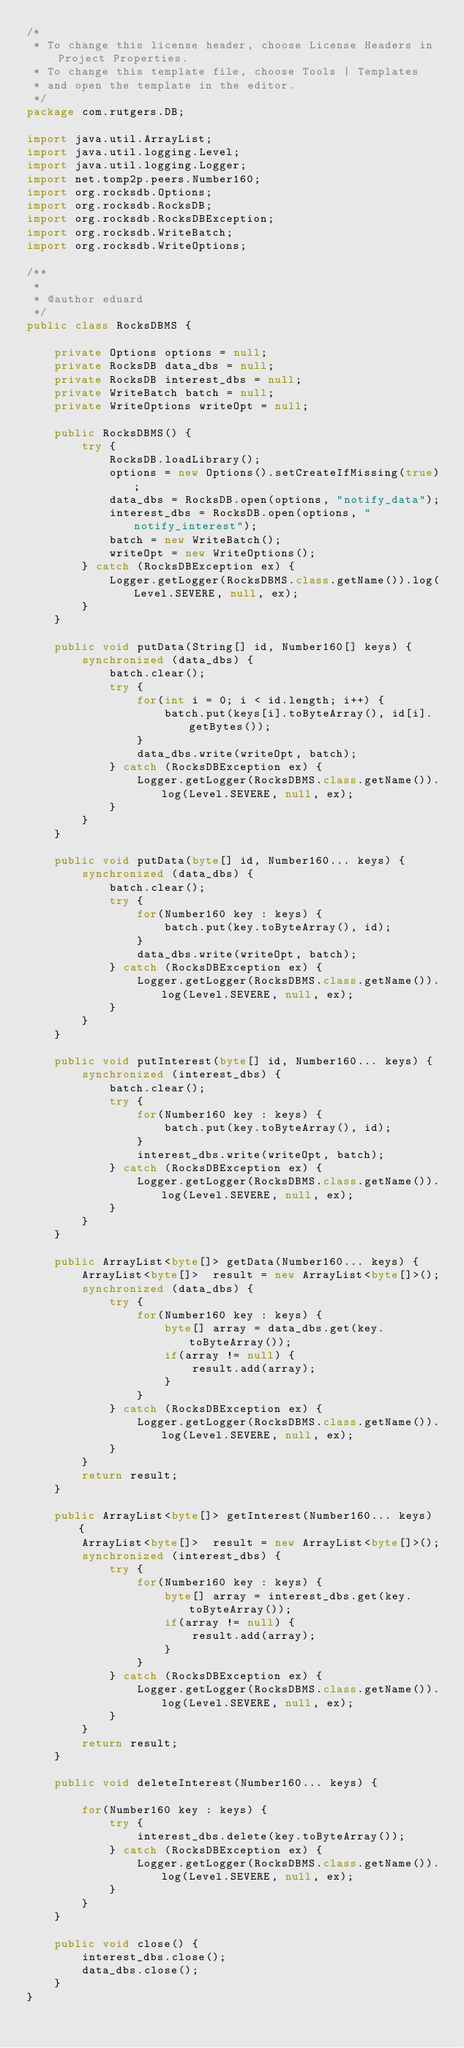<code> <loc_0><loc_0><loc_500><loc_500><_Java_>/*
 * To change this license header, choose License Headers in Project Properties.
 * To change this template file, choose Tools | Templates
 * and open the template in the editor.
 */
package com.rutgers.DB;

import java.util.ArrayList;
import java.util.logging.Level;
import java.util.logging.Logger;
import net.tomp2p.peers.Number160;
import org.rocksdb.Options;
import org.rocksdb.RocksDB;
import org.rocksdb.RocksDBException;
import org.rocksdb.WriteBatch;
import org.rocksdb.WriteOptions;

/**
 *
 * @author eduard
 */
public class RocksDBMS {
    
    private Options options = null;
    private RocksDB data_dbs = null;
    private RocksDB interest_dbs = null;
    private WriteBatch batch = null;
    private WriteOptions writeOpt = null;
    
    public RocksDBMS() {
        try {
            RocksDB.loadLibrary();            
            options = new Options().setCreateIfMissing(true);
            data_dbs = RocksDB.open(options, "notify_data");
            interest_dbs = RocksDB.open(options, "notify_interest");
            batch = new WriteBatch();
            writeOpt = new WriteOptions();
        } catch (RocksDBException ex) {
            Logger.getLogger(RocksDBMS.class.getName()).log(Level.SEVERE, null, ex);
        }
    }
    
    public void putData(String[] id, Number160[] keys) {
        synchronized (data_dbs) {
            batch.clear();
            try {
                for(int i = 0; i < id.length; i++) {
                    batch.put(keys[i].toByteArray(), id[i].getBytes());
                }
                data_dbs.write(writeOpt, batch);
            } catch (RocksDBException ex) {
                Logger.getLogger(RocksDBMS.class.getName()).log(Level.SEVERE, null, ex);
            }
        }
    }
    
    public void putData(byte[] id, Number160... keys) {
        synchronized (data_dbs) {
            batch.clear();
            try {
                for(Number160 key : keys) {
                    batch.put(key.toByteArray(), id);
                }
                data_dbs.write(writeOpt, batch);
            } catch (RocksDBException ex) {
                Logger.getLogger(RocksDBMS.class.getName()).log(Level.SEVERE, null, ex);
            }
        }
    }
    
    public void putInterest(byte[] id, Number160... keys) {
        synchronized (interest_dbs) {
            batch.clear();
            try {
                for(Number160 key : keys) {
                    batch.put(key.toByteArray(), id);
                }
                interest_dbs.write(writeOpt, batch);
            } catch (RocksDBException ex) {
                Logger.getLogger(RocksDBMS.class.getName()).log(Level.SEVERE, null, ex);
            }
        }
    }
    
    public ArrayList<byte[]> getData(Number160... keys) {
        ArrayList<byte[]>  result = new ArrayList<byte[]>();
        synchronized (data_dbs) {
            try {
                for(Number160 key : keys) {                    
                    byte[] array = data_dbs.get(key.toByteArray());
                    if(array != null) {
                        result.add(array);
                    }
                }
            } catch (RocksDBException ex) {
                Logger.getLogger(RocksDBMS.class.getName()).log(Level.SEVERE, null, ex);
            }
        }
        return result;  
    }

    public ArrayList<byte[]> getInterest(Number160... keys) {
        ArrayList<byte[]>  result = new ArrayList<byte[]>();
        synchronized (interest_dbs) {
            try {
                for(Number160 key : keys) {                    
                    byte[] array = interest_dbs.get(key.toByteArray());
                    if(array != null) {
                        result.add(array);
                    }
                }
            } catch (RocksDBException ex) {
                Logger.getLogger(RocksDBMS.class.getName()).log(Level.SEVERE, null, ex);
            }
        }
        return result;  
    }
    
    public void deleteInterest(Number160... keys) {
        
        for(Number160 key : keys) {                    
            try {
                interest_dbs.delete(key.toByteArray());
            } catch (RocksDBException ex) {
                Logger.getLogger(RocksDBMS.class.getName()).log(Level.SEVERE, null, ex);
            }
        }
    }
    
    public void close() {
        interest_dbs.close();
        data_dbs.close();
    }
}
</code> 